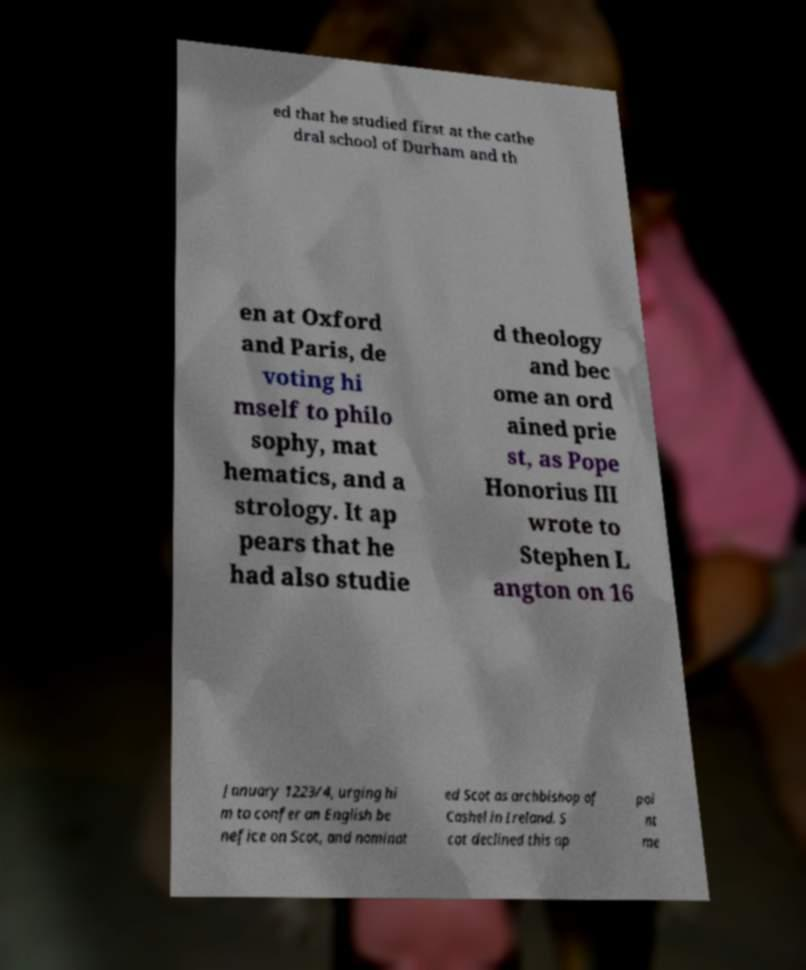Please identify and transcribe the text found in this image. ed that he studied first at the cathe dral school of Durham and th en at Oxford and Paris, de voting hi mself to philo sophy, mat hematics, and a strology. It ap pears that he had also studie d theology and bec ome an ord ained prie st, as Pope Honorius III wrote to Stephen L angton on 16 January 1223/4, urging hi m to confer an English be nefice on Scot, and nominat ed Scot as archbishop of Cashel in Ireland. S cot declined this ap poi nt me 